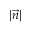Convert formula to latex. <formula><loc_0><loc_0><loc_500><loc_500>| { \vec { n } } |</formula> 